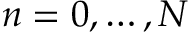Convert formula to latex. <formula><loc_0><loc_0><loc_500><loc_500>n = 0 , \dots , N</formula> 